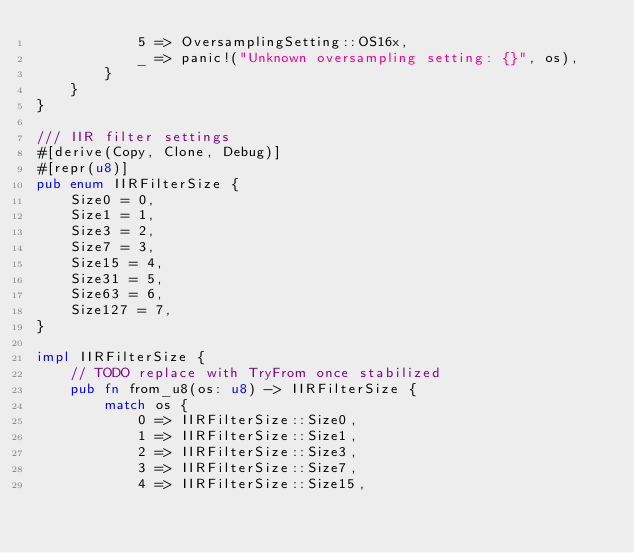<code> <loc_0><loc_0><loc_500><loc_500><_Rust_>            5 => OversamplingSetting::OS16x,
            _ => panic!("Unknown oversampling setting: {}", os),
        }
    }
}

/// IIR filter settings
#[derive(Copy, Clone, Debug)]
#[repr(u8)]
pub enum IIRFilterSize {
    Size0 = 0,
    Size1 = 1,
    Size3 = 2,
    Size7 = 3,
    Size15 = 4,
    Size31 = 5,
    Size63 = 6,
    Size127 = 7,
}

impl IIRFilterSize {
    // TODO replace with TryFrom once stabilized
    pub fn from_u8(os: u8) -> IIRFilterSize {
        match os {
            0 => IIRFilterSize::Size0,
            1 => IIRFilterSize::Size1,
            2 => IIRFilterSize::Size3,
            3 => IIRFilterSize::Size7,
            4 => IIRFilterSize::Size15,</code> 